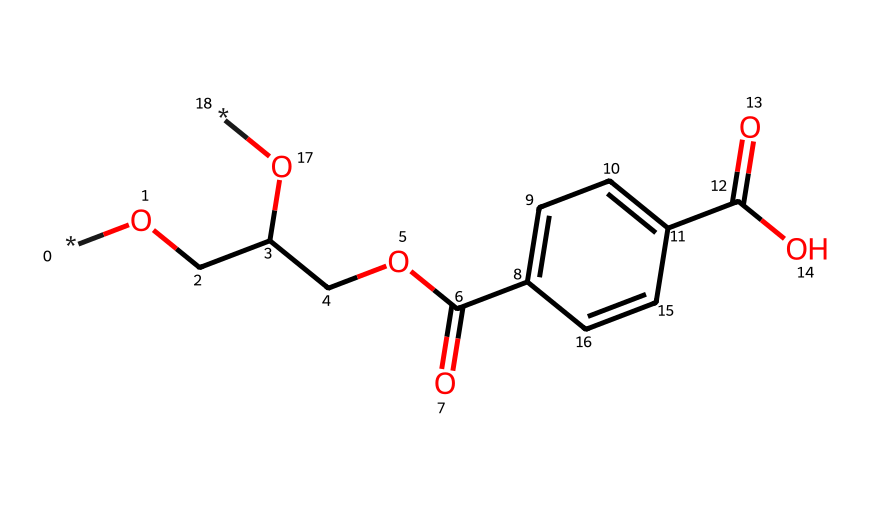what is the primary aromatic group present in this structure? The structure contains a phenyl ring (aromatic compound) connected to the aliphatic part of the molecule. This can be determined by identifying the ring with alternating double bonds, which is characteristic of benzene derivatives.
Answer: phenyl how many carbon atoms are present in the molecule? By analyzing the SMILES representation and counting each 'C', we see there are a total of 12 carbon atoms in the structure. This can be confirmed by inspecting each segment and summing them up.
Answer: 12 which functional group indicates the presence of an ester in the structure? The -COO- group identified in the structure reflects the ester functional group, recognized by the carbon atom bonded to an oxygen atom which is also bonded to another carbon. In this case, it connects the aliphatic and aromatic sections of the molecule.
Answer: -COO- does this molecule have hydroxyl groups? Yes, the presence of -OH groups can be noted in the structure, where the oxygen is bonded to hydrogen, indicating it is a hydroxyl group. In this case, two -OH groups are present in the aliphatic portion of the structure.
Answer: yes what is the molecular formula for this compound? By counting the atoms represented in the structure, including 12 carbon, 10 hydrogen, and 5 oxygen atoms, the molecular formula can be deduced as C12H10O5. This sum includes all the components derived from the structure.
Answer: C12H10O5 what does the presence of the carboxylic acid (-COOH) suggest about the compound? The appearance of the -COOH group signifies that the compound has acidic properties. This can be concluded from the carbon connected to an oxygen with a double bond and a hydroxyl group, which together form the acid functionality.
Answer: acidic properties 